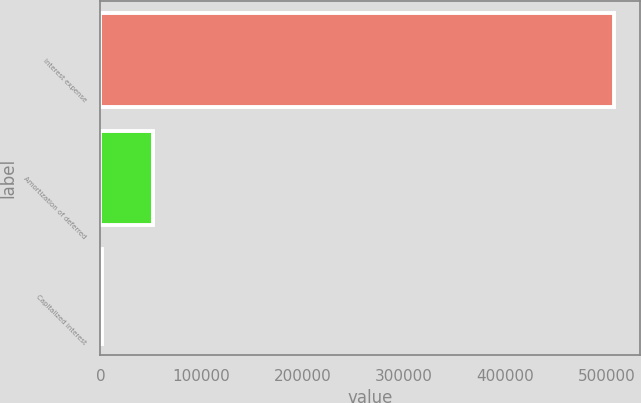Convert chart. <chart><loc_0><loc_0><loc_500><loc_500><bar_chart><fcel>Interest expense<fcel>Amortization of deferred<fcel>Capitalized interest<nl><fcel>507387<fcel>51816<fcel>1197<nl></chart> 